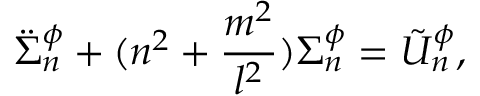<formula> <loc_0><loc_0><loc_500><loc_500>\ddot { \Sigma } _ { n } ^ { \phi } + ( n ^ { 2 } + \frac { m ^ { 2 } } { l ^ { 2 } } ) \Sigma _ { n } ^ { \phi } = \tilde { U } _ { n } ^ { \phi } ,</formula> 